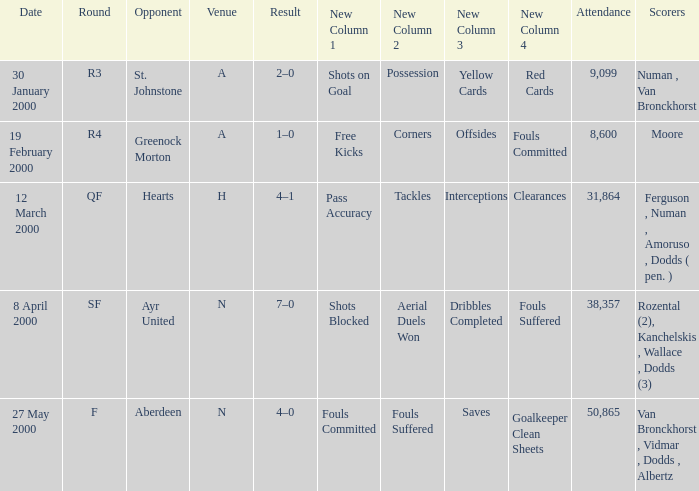Who was in a with opponent St. Johnstone? Numan , Van Bronckhorst. 